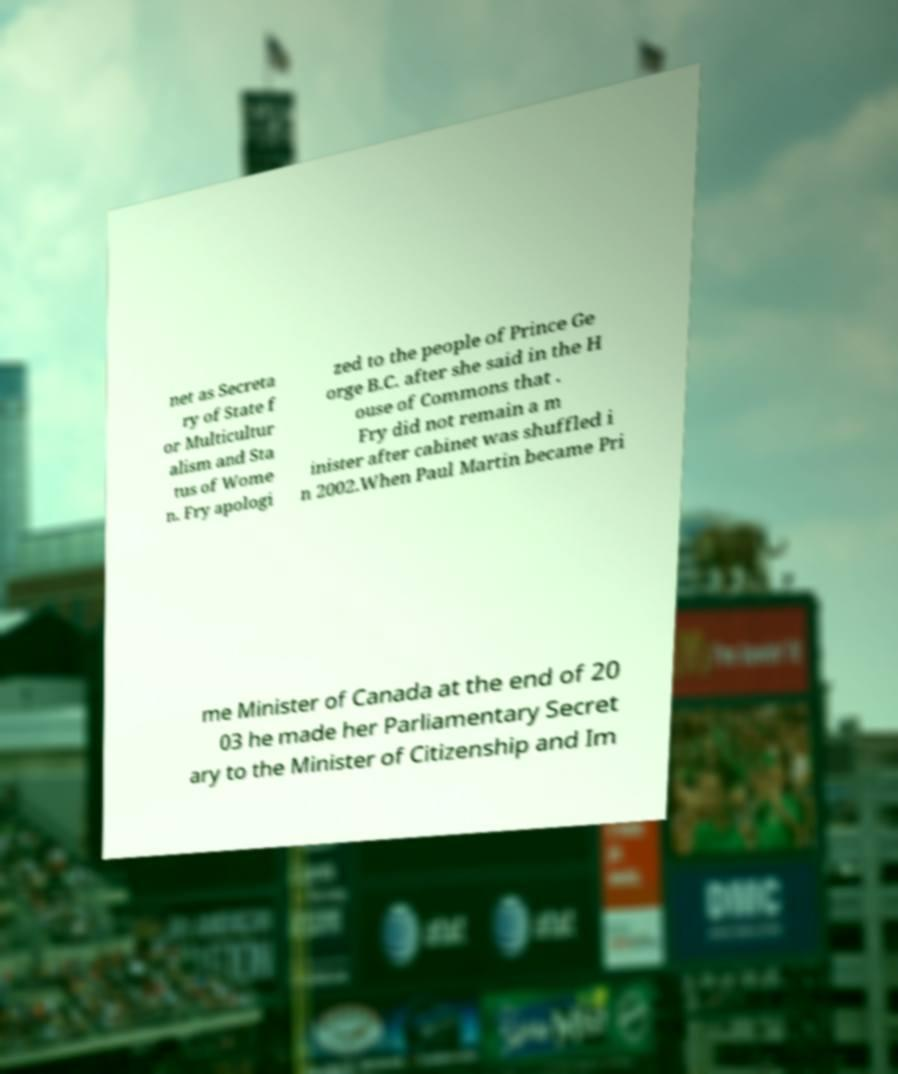Can you accurately transcribe the text from the provided image for me? net as Secreta ry of State f or Multicultur alism and Sta tus of Wome n. Fry apologi zed to the people of Prince Ge orge B.C. after she said in the H ouse of Commons that . Fry did not remain a m inister after cabinet was shuffled i n 2002.When Paul Martin became Pri me Minister of Canada at the end of 20 03 he made her Parliamentary Secret ary to the Minister of Citizenship and Im 